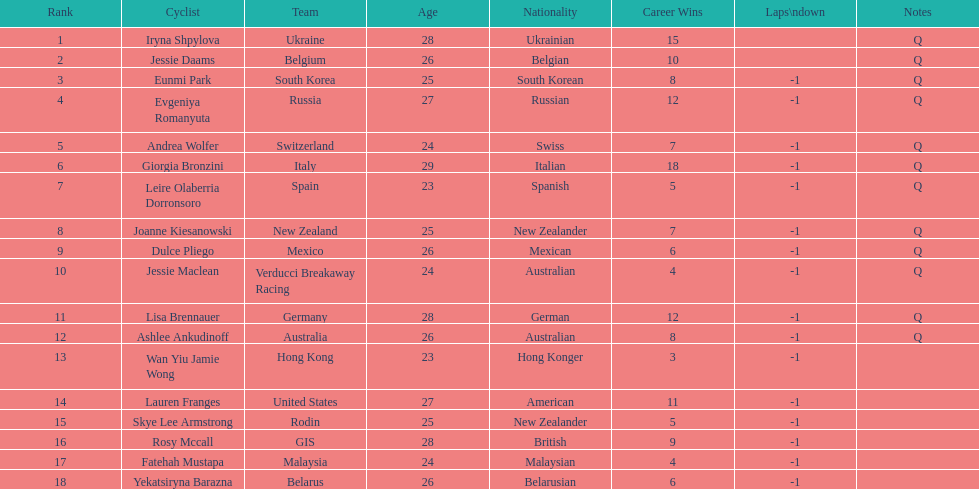What is the number rank of belgium? 2. 